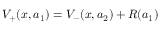<formula> <loc_0><loc_0><loc_500><loc_500>V _ { + } ( x , a _ { 1 } ) = V _ { - } ( x , a _ { 2 } ) + R ( a _ { 1 } )</formula> 